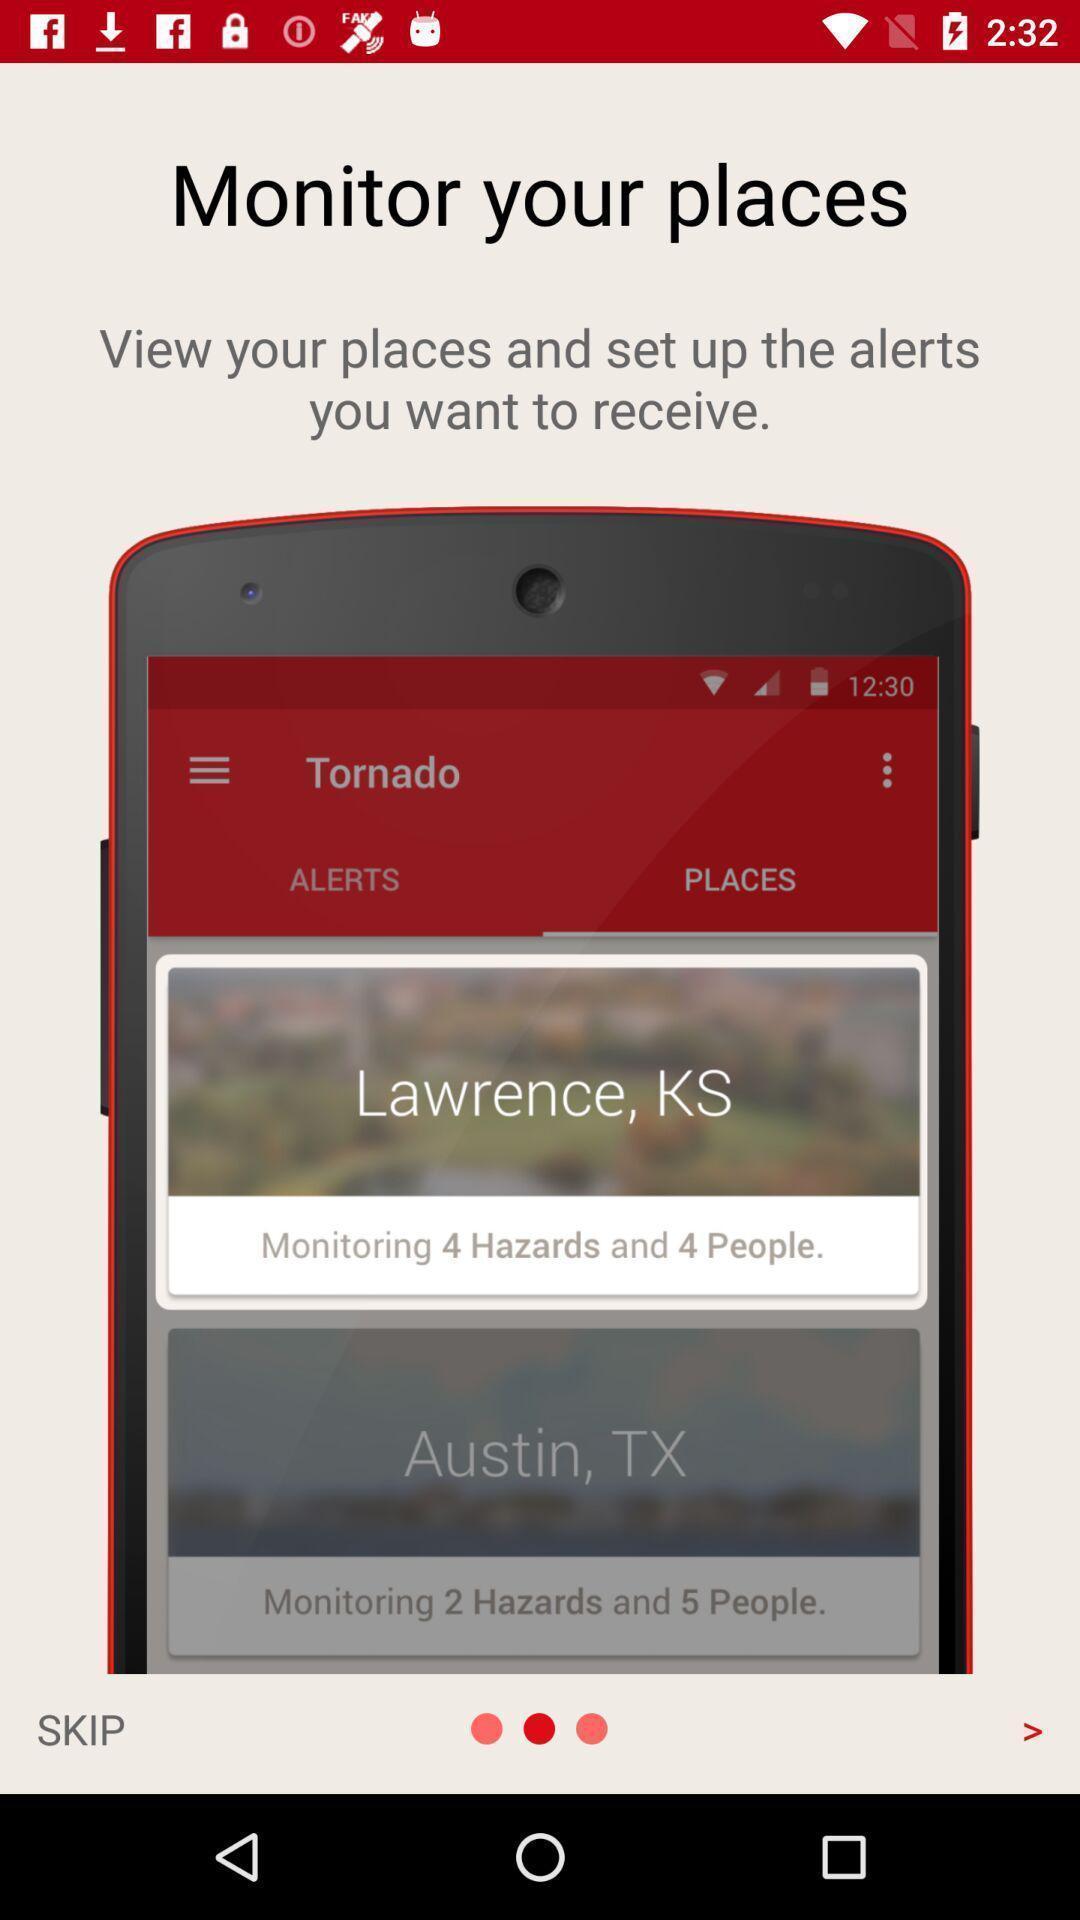Describe the content in this image. Welcome page to the application with information. 